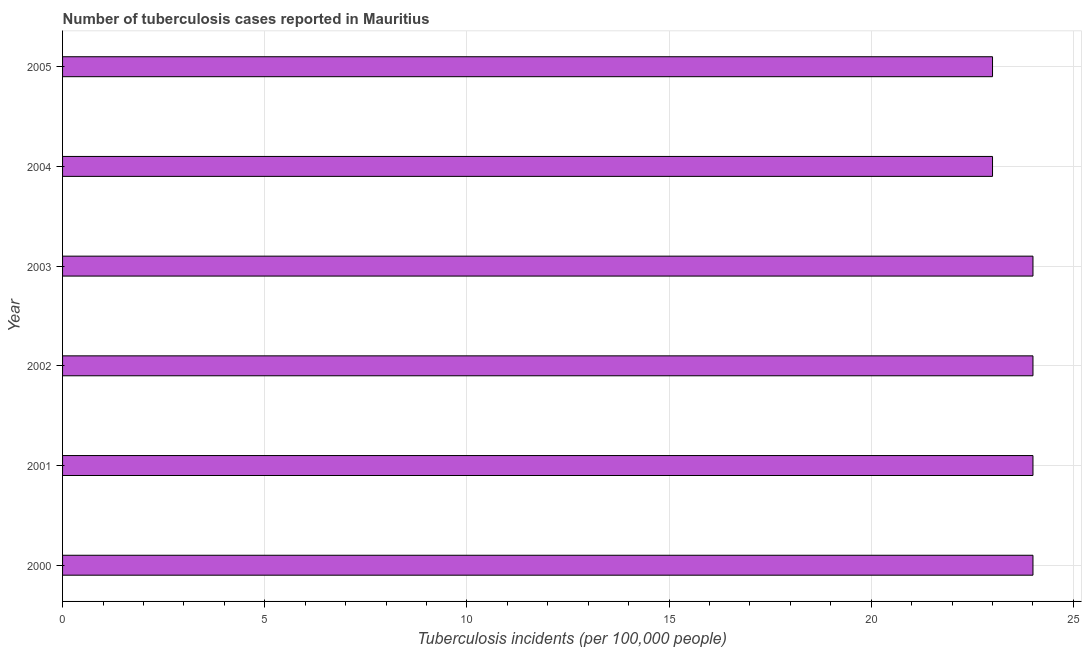Does the graph contain any zero values?
Make the answer very short. No. What is the title of the graph?
Give a very brief answer. Number of tuberculosis cases reported in Mauritius. What is the label or title of the X-axis?
Your answer should be very brief. Tuberculosis incidents (per 100,0 people). What is the label or title of the Y-axis?
Offer a terse response. Year. Across all years, what is the minimum number of tuberculosis incidents?
Give a very brief answer. 23. In which year was the number of tuberculosis incidents minimum?
Keep it short and to the point. 2004. What is the sum of the number of tuberculosis incidents?
Provide a short and direct response. 142. What is the difference between the number of tuberculosis incidents in 2001 and 2002?
Your answer should be very brief. 0. In how many years, is the number of tuberculosis incidents greater than 20 ?
Your answer should be very brief. 6. Do a majority of the years between 2001 and 2005 (inclusive) have number of tuberculosis incidents greater than 6 ?
Your answer should be very brief. Yes. What is the ratio of the number of tuberculosis incidents in 2000 to that in 2004?
Ensure brevity in your answer.  1.04. Is the difference between the number of tuberculosis incidents in 2002 and 2003 greater than the difference between any two years?
Provide a short and direct response. No. What is the difference between the highest and the second highest number of tuberculosis incidents?
Offer a terse response. 0. In how many years, is the number of tuberculosis incidents greater than the average number of tuberculosis incidents taken over all years?
Your response must be concise. 4. How many bars are there?
Your answer should be compact. 6. Are all the bars in the graph horizontal?
Offer a very short reply. Yes. How many years are there in the graph?
Offer a terse response. 6. What is the difference between two consecutive major ticks on the X-axis?
Make the answer very short. 5. Are the values on the major ticks of X-axis written in scientific E-notation?
Your answer should be very brief. No. What is the Tuberculosis incidents (per 100,000 people) of 2001?
Offer a terse response. 24. What is the Tuberculosis incidents (per 100,000 people) of 2002?
Provide a succinct answer. 24. What is the Tuberculosis incidents (per 100,000 people) in 2004?
Provide a succinct answer. 23. What is the Tuberculosis incidents (per 100,000 people) in 2005?
Your answer should be very brief. 23. What is the difference between the Tuberculosis incidents (per 100,000 people) in 2000 and 2001?
Your answer should be very brief. 0. What is the difference between the Tuberculosis incidents (per 100,000 people) in 2000 and 2003?
Keep it short and to the point. 0. What is the difference between the Tuberculosis incidents (per 100,000 people) in 2000 and 2004?
Your answer should be compact. 1. What is the difference between the Tuberculosis incidents (per 100,000 people) in 2000 and 2005?
Make the answer very short. 1. What is the difference between the Tuberculosis incidents (per 100,000 people) in 2001 and 2002?
Offer a very short reply. 0. What is the difference between the Tuberculosis incidents (per 100,000 people) in 2001 and 2003?
Offer a terse response. 0. What is the difference between the Tuberculosis incidents (per 100,000 people) in 2001 and 2005?
Make the answer very short. 1. What is the difference between the Tuberculosis incidents (per 100,000 people) in 2002 and 2003?
Provide a short and direct response. 0. What is the difference between the Tuberculosis incidents (per 100,000 people) in 2002 and 2005?
Give a very brief answer. 1. What is the difference between the Tuberculosis incidents (per 100,000 people) in 2003 and 2004?
Offer a terse response. 1. What is the difference between the Tuberculosis incidents (per 100,000 people) in 2004 and 2005?
Offer a terse response. 0. What is the ratio of the Tuberculosis incidents (per 100,000 people) in 2000 to that in 2001?
Provide a succinct answer. 1. What is the ratio of the Tuberculosis incidents (per 100,000 people) in 2000 to that in 2003?
Your response must be concise. 1. What is the ratio of the Tuberculosis incidents (per 100,000 people) in 2000 to that in 2004?
Offer a terse response. 1.04. What is the ratio of the Tuberculosis incidents (per 100,000 people) in 2000 to that in 2005?
Your response must be concise. 1.04. What is the ratio of the Tuberculosis incidents (per 100,000 people) in 2001 to that in 2004?
Keep it short and to the point. 1.04. What is the ratio of the Tuberculosis incidents (per 100,000 people) in 2001 to that in 2005?
Provide a short and direct response. 1.04. What is the ratio of the Tuberculosis incidents (per 100,000 people) in 2002 to that in 2004?
Provide a succinct answer. 1.04. What is the ratio of the Tuberculosis incidents (per 100,000 people) in 2002 to that in 2005?
Keep it short and to the point. 1.04. What is the ratio of the Tuberculosis incidents (per 100,000 people) in 2003 to that in 2004?
Offer a very short reply. 1.04. What is the ratio of the Tuberculosis incidents (per 100,000 people) in 2003 to that in 2005?
Provide a succinct answer. 1.04. What is the ratio of the Tuberculosis incidents (per 100,000 people) in 2004 to that in 2005?
Make the answer very short. 1. 